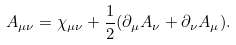<formula> <loc_0><loc_0><loc_500><loc_500>A _ { \mu \nu } = \chi _ { \mu \nu } + \frac { 1 } { 2 } ( \partial _ { \mu } A _ { \nu } + \partial _ { \nu } A _ { \mu } ) .</formula> 